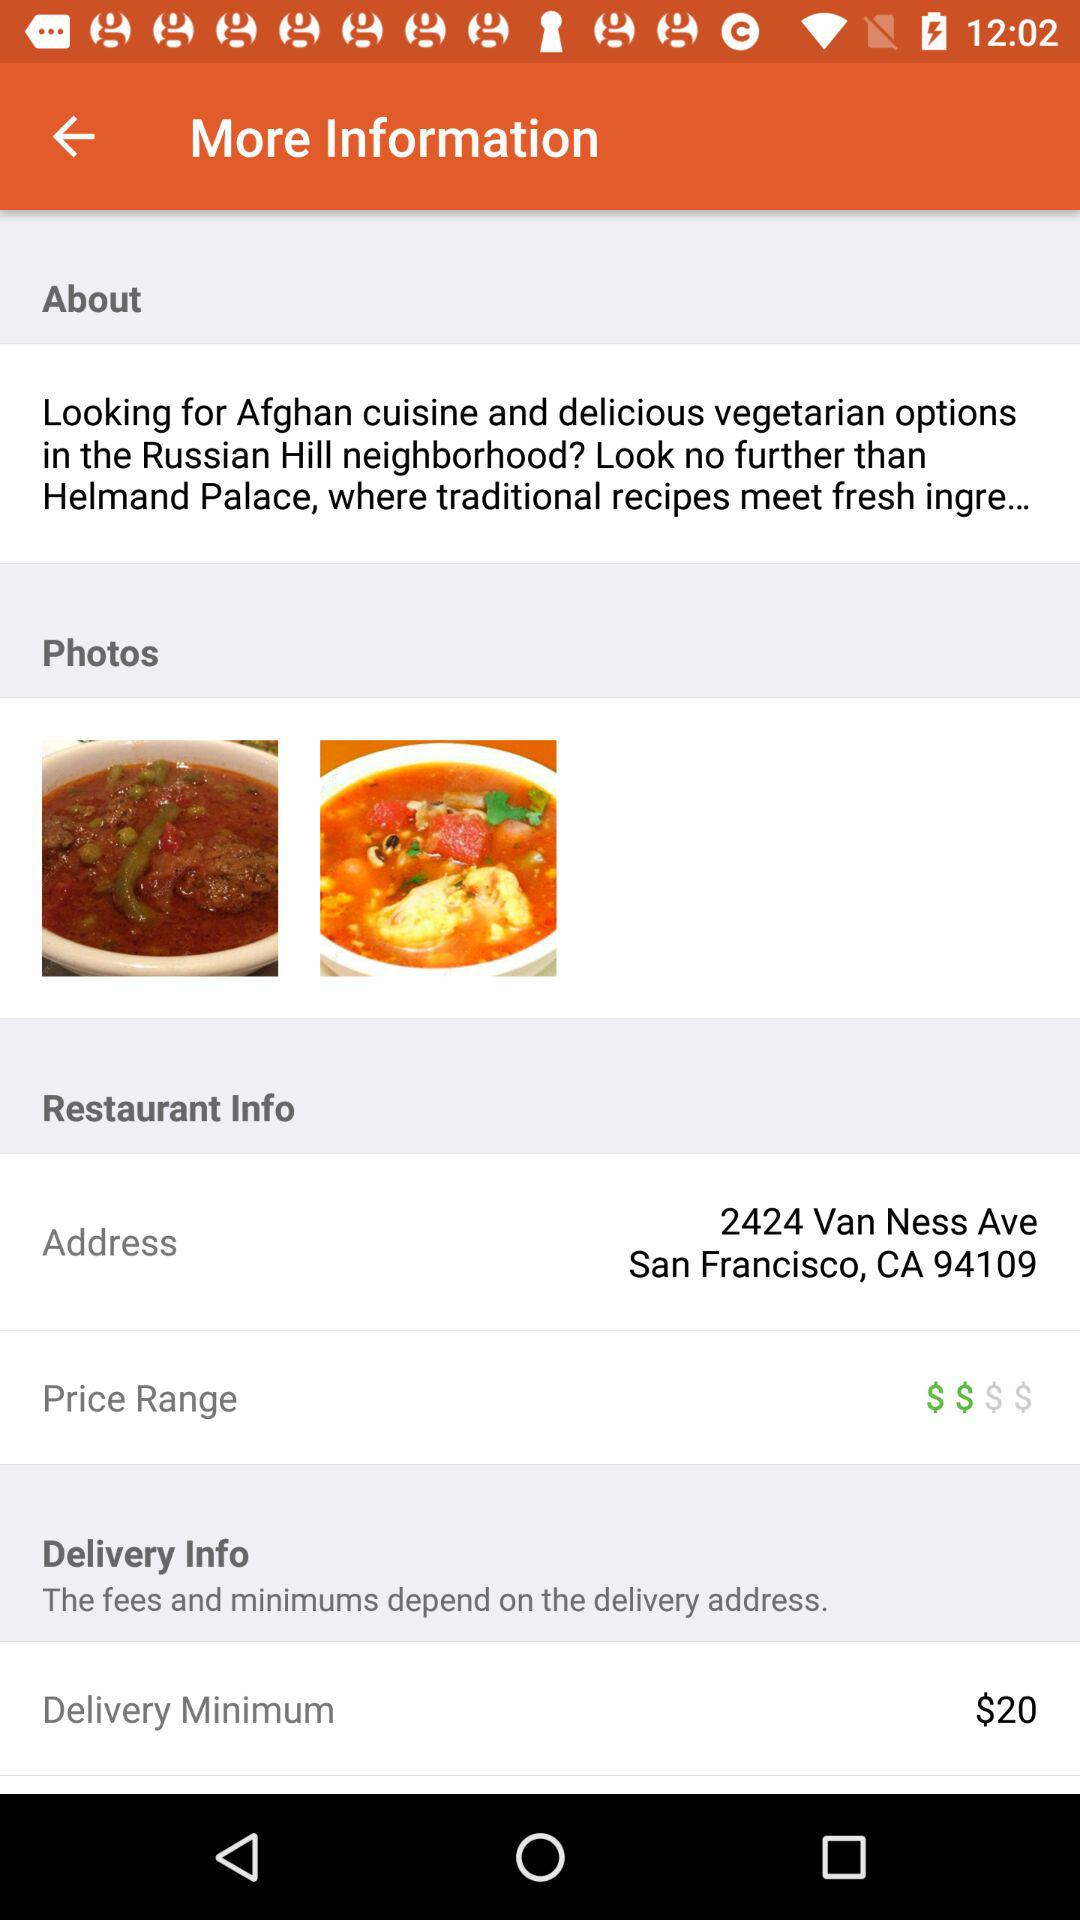How much is the delivery minimum?
Answer the question using a single word or phrase. $20 